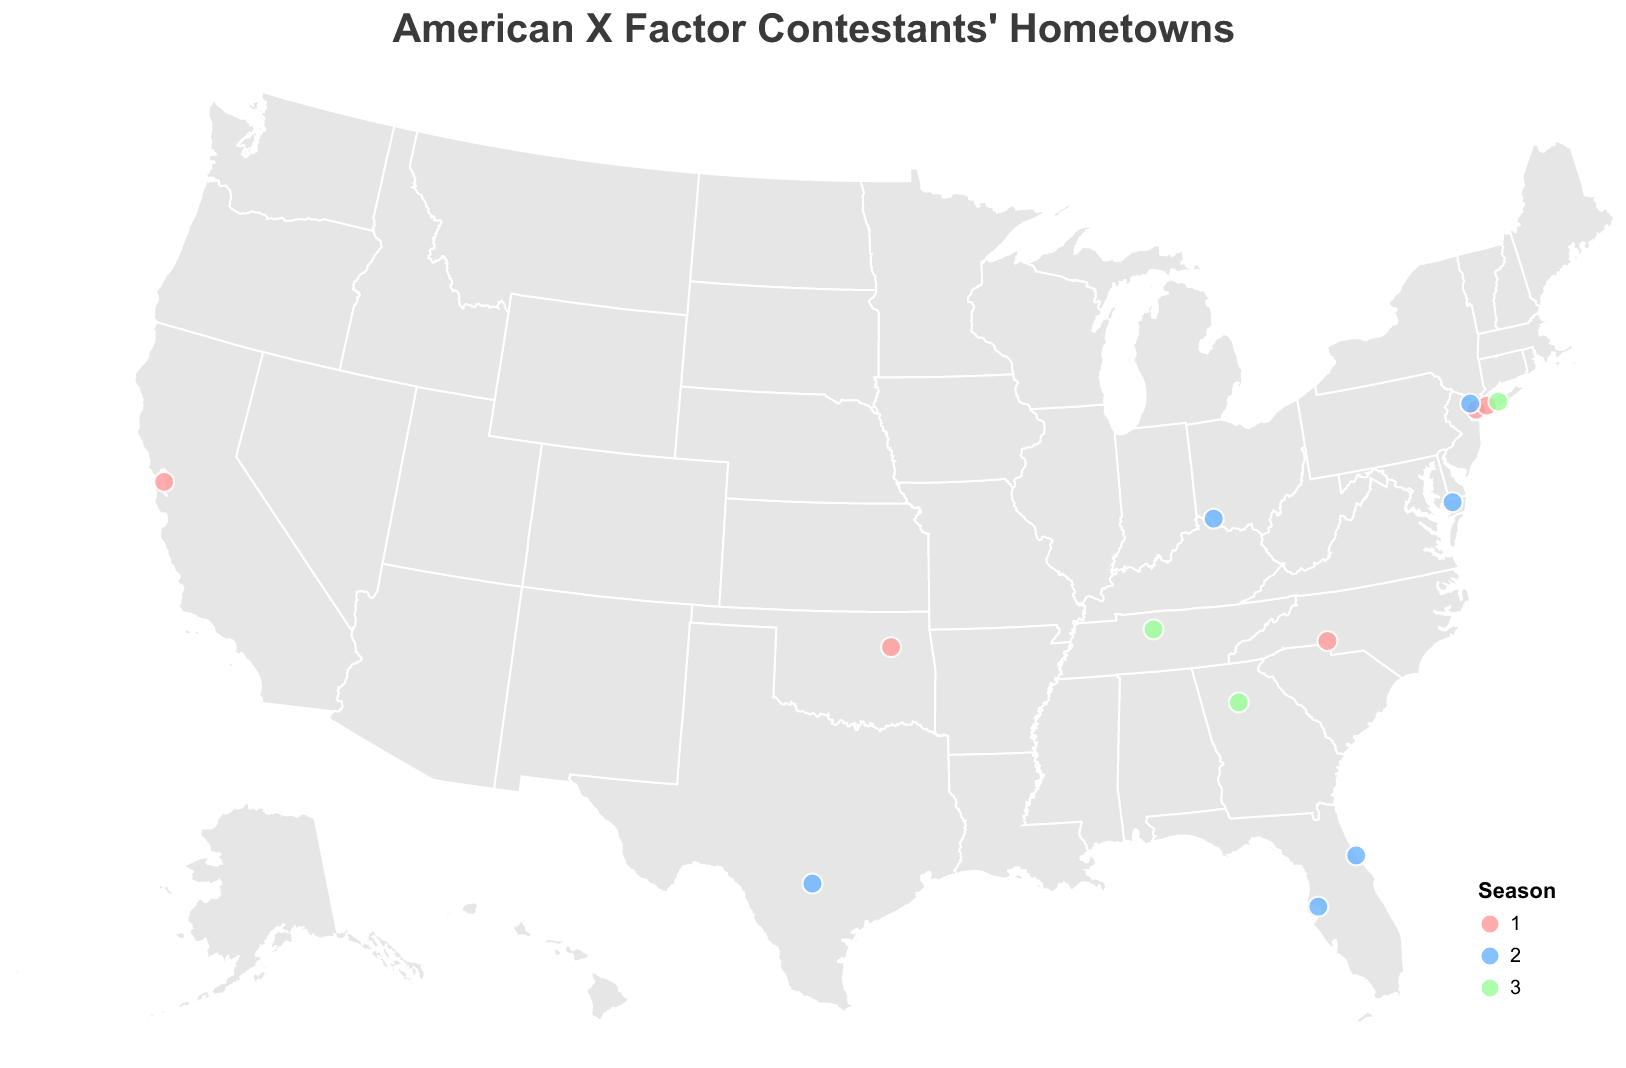How many contestants on the map are from New York? Count the number of contestants listed within the New York (NY) state. Look for dots placed in New York and identify them using the tooltips. There are three contestants: Melanie Amaro, Josh Krajcik, and Jeff Gutt.
Answer: 3 Which region seems to have the highest concentration of successful contestants? Observe the map and notice where the circles (representing the contestants' hometowns) are clustered more densely. The northeast region (particularly New York and nearby areas) has multiple contestants.
Answer: Northeast region How many winners are from Florida? Identify the circles corresponding to Florida and check their tooltips to see how many contestants finished as "Winners". There are two instances of Tate Stevens, so count it as one unique winner.
Answer: 1 Which contestant is from the furthest west city? Look for the circle that is placed furthest to the left on the map representing western cities. Upon identifying Oakland, CA, check the tooltip to find Chris Rene.
Answer: Chris Rene Compare the number of contestants from Seasons 1 and 2. Which season has more contestants? Count the dots coded with colors for Season 1 (pink) and Season 2 (blue) separately. Season 1 has 5 contestants, and Season 2 has 7 contestants. Season 2 has more contestants.
Answer: Season 2 What is the average latitude of contestants from Season 3? First, locate all the dots representing Season 3 (green) contestants and note their latitudes: Nashville, TN (36.1627), Long Island, NY (40.7891), and Lilburn, GA (33.8901). Calculate the average: (36.1627 + 40.7891 + 33.8901) / 3 = 36.28063.
Answer: ~36.28 Are there more winning contestants from the eastern or western states? Identify all winning contestants and their locations: eastern states (New York, Florida, Tennessee) vs. western states (none). The eastern states have 3 winners, confirming they predominate.
Answer: Eastern states Which contestant from Season 2 finished 9th place, and from which state are they? Look for the tooltip indicating "Season: 2" and "Placement: 9th Place". This matches Beatrice Miller from Paterson, NJ.
Answer: Beatrice Miller from New Jersey Which states have contestants who placed in the top three positions across all seasons? Identify the contestants and placements in each season, focusing on the top three (Winner, Runner-up, Third Place). The states are New York (Melanie Amaro, Josh Krajcik, Jeff Gutt), California (Chris Rene), Florida (Tate Stevens), Tennessee (Alex & Sierra), Georgia (Carlito Olivero), and Texas (Carly Rose Sonenclar), Maryland (Fifth Harmony).
Answer: New York, California, Florida, Tennessee, Georgia, Texas, Maryland 